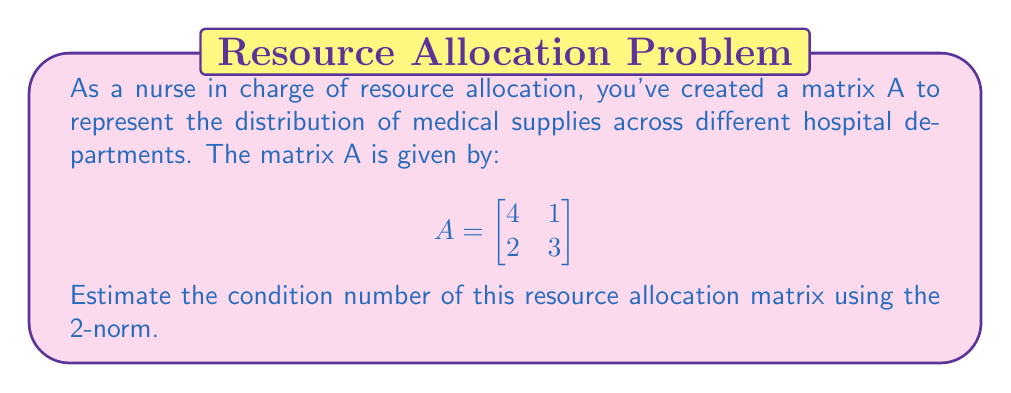Help me with this question. To estimate the condition number of matrix A using the 2-norm, we need to follow these steps:

1. Calculate the eigenvalues of $A^TA$:
   $A^TA = \begin{bmatrix}
   4 & 2 \\
   1 & 3
   \end{bmatrix} \begin{bmatrix}
   4 & 1 \\
   2 & 3
   \end{bmatrix} = \begin{bmatrix}
   20 & 10 \\
   10 & 10
   \end{bmatrix}$

2. Find the characteristic equation:
   $det(A^TA - \lambda I) = \begin{vmatrix}
   20-\lambda & 10 \\
   10 & 10-\lambda
   \end{vmatrix} = (20-\lambda)(10-\lambda) - 100 = \lambda^2 - 30\lambda + 100 = 0$

3. Solve for eigenvalues:
   $\lambda = \frac{30 \pm \sqrt{900 - 400}}{2} = \frac{30 \pm \sqrt{500}}{2} = 15 \pm 5\sqrt{5}$

4. The largest eigenvalue is $\lambda_{max} = 15 + 5\sqrt{5}$, and the smallest is $\lambda_{min} = 15 - 5\sqrt{5}$

5. The singular values of A are the square roots of these eigenvalues:
   $\sigma_{max} = \sqrt{15 + 5\sqrt{5}}$ and $\sigma_{min} = \sqrt{15 - 5\sqrt{5}}$

6. The condition number is the ratio of the largest to the smallest singular value:
   $\kappa(A) = \frac{\sigma_{max}}{\sigma_{min}} = \frac{\sqrt{15 + 5\sqrt{5}}}{\sqrt{15 - 5\sqrt{5}}}$

7. Simplify:
   $\kappa(A) = \sqrt{\frac{15 + 5\sqrt{5}}{15 - 5\sqrt{5}}} \approx 2.6180$
Answer: $\kappa(A) \approx 2.6180$ 